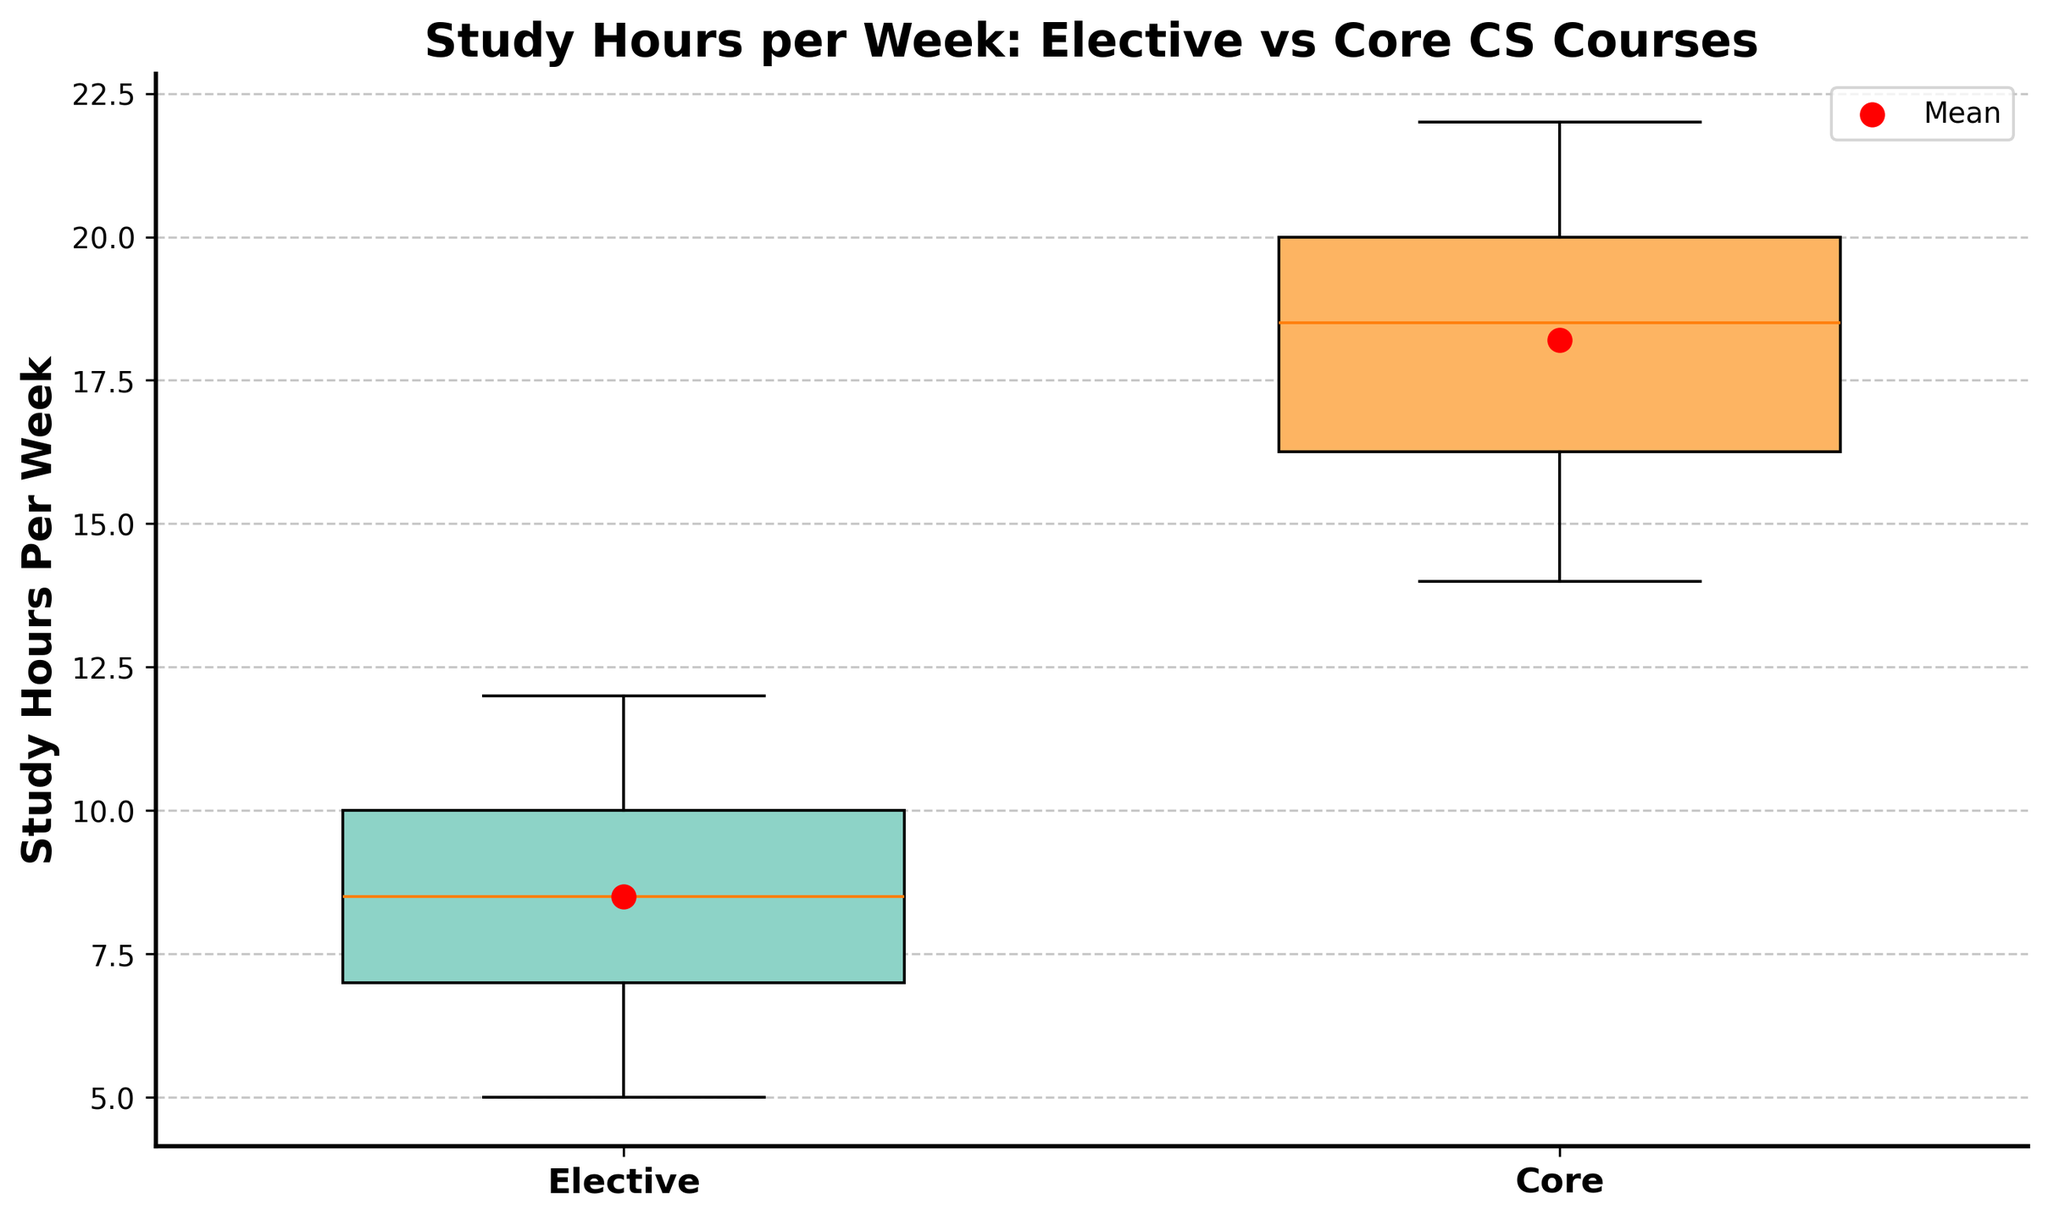What is the title of the plot? The title is displayed at the top of the plot. The text reads "Study Hours per Week: Elective vs Core CS Courses".
Answer: Study Hours per Week: Elective vs Core CS Courses What are the labels on the x-axis? The x-axis labels are displayed at the bottom of the plot, under each box plot. They read "Elective" and "Core".
Answer: Elective and Core How many groups are compared in the plot? The plot compares two groups, as visually indicated by two separate box plots. The x-axis also labels two categories: "Elective" and "Core".
Answer: 2 Which group has the higher mean study hours per week, Elective or Core? The mean study hours for each group is shown as a red dot on the plot. The red dot in the Core group is higher above the y-axis than the one in the Elective group.
Answer: Core What is the mean study hours per week for students taking Core courses? The red dot represents the mean, and it's visually located at 18 hours for the Core group.
Answer: 18 What is the median study hours per week for students taking Elective courses? The median is represented by the line inside the box plot's rectangular body. It appears to be at the 8-hour mark for the Elective group.
Answer: 8 Which group has a larger interquartile range (IQR), Elective or Core? The IQR is the range between the first quartile (Q1) and the third quartile (Q3), which are the lower and upper edges of the box, respectively. The Core group box appears taller, indicating a larger IQR than the Elective group.
Answer: Core What is the maximum study hours per week for students taking Elective courses? The maximum value is indicated by the top whisker of the box plot for the Elective group. It is at 12 hours.
Answer: 12 Compare the minimum study hours per week between Elective and Core courses. Which has a higher minimum? The minimum value is indicated by the bottom whisker for each box plot. The Elective group has a minimum of 5 hours, whereas the Core group has a minimum of 14 hours.
Answer: Core What is the range of study hours per week for students taking Core courses? The range is the difference between the maximum and minimum values. For Core courses, the maximum is 22 hours, and the minimum is 14 hours. The range is therefore 22 - 14 = 8 hours.
Answer: 8 